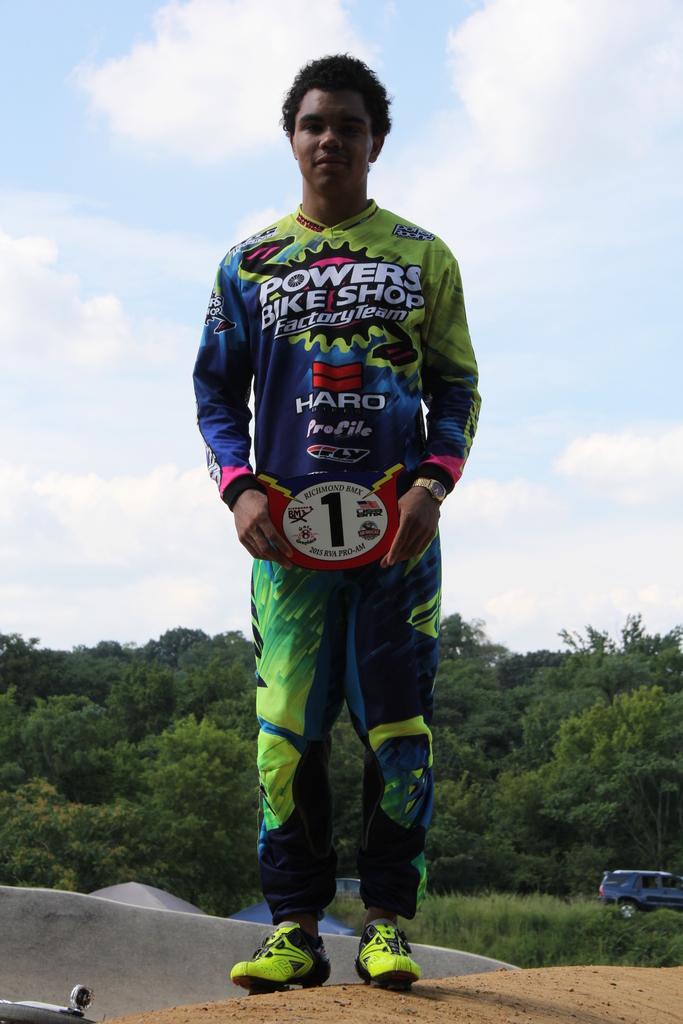What number is displayed?
Offer a terse response. 1. 